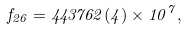<formula> <loc_0><loc_0><loc_500><loc_500>f _ { 2 6 } = 4 4 3 7 6 2 ( 4 ) \times 1 0 ^ { 7 } ,</formula> 